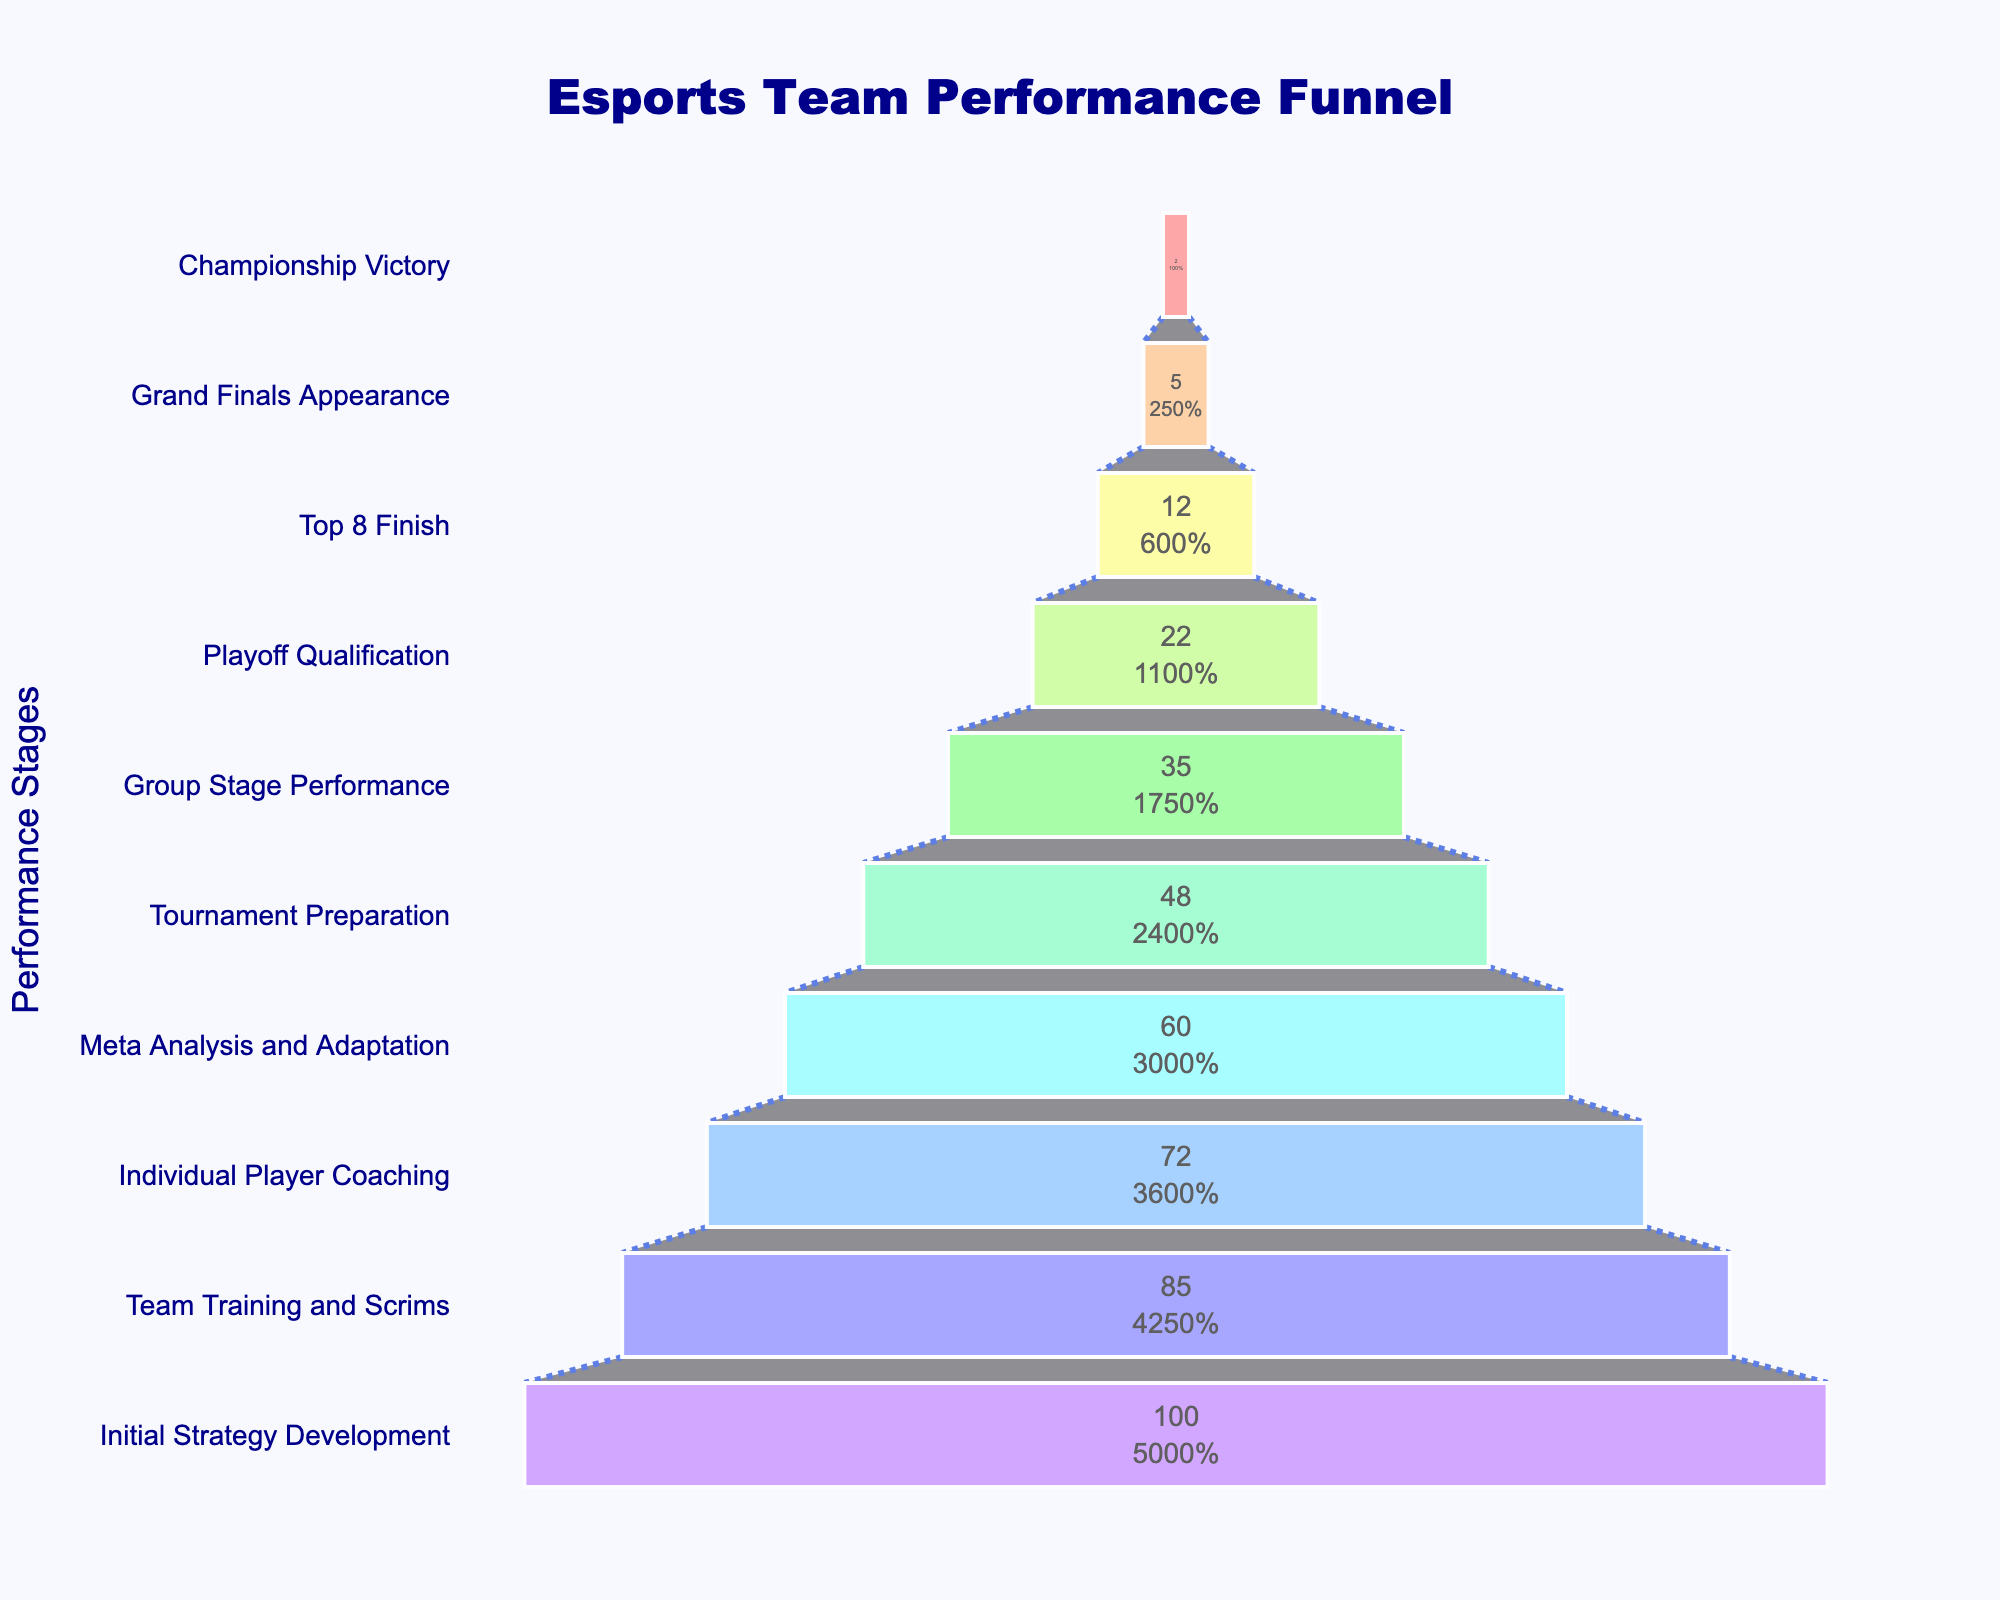How many teams participated in initial strategy development? The first stage shown in the funnel chart is "Initial Strategy Development," and it lists the number of teams as shown in the value.
Answer: 100 Which stage has the lowest number of teams? By looking at the bottom of the funnel, we can see that the stage "Championship Victory" has the smallest value in terms of the number of teams.
Answer: Championship Victory What's the change in the number of teams from "Team Training and Scrims" to "Individual Player Coaching"? To find the change, we subtract the number of teams at the "Individual Player Coaching" stage from "Team Training and Scrims": 85 - 72 = 13.
Answer: 13 What percentage of teams move from "Group Stage Performance" to "Playoff Qualification"? To calculate the percentage, we use the formula: (Teams in "Playoff Qualification"/Teams in "Group Stage Performance") * 100. This is (22/35) * 100 ≈ 62.86%.
Answer: 62.86% Which stage sees the largest drop in the number of teams? We look for the biggest difference between consecutive stages. The largest drop is between "Group Stage Performance" (35 teams) and "Playoff Qualification" (22 teams), which is 35 - 22 = 13 teams.
Answer: Group Stage Performance to Playoff Qualification What is the average number of teams from "Initial Strategy Development" to "Tournament Preparation"? Add the number of teams from these stages and divide by the number of stages: (100 + 85 + 72 + 60 + 48) / 5 = 365 / 5 = 73.
Answer: 73 How many stages are shown in the funnel chart? Counting the number of distinct stages listed on the y-axis of the funnel chart gives the total number of stages.
Answer: 10 Are there more teams in "Meta Analysis and Adaptation" than "Group Stage Performance"? Compare the values of both stages in the chart; "Meta Analysis and Adaptation" has 60 teams while "Group Stage Performance" has 35 teams.
Answer: Yes What's the percentage drop in the number of teams from the "Top 8 Finish" to "Grand Finals Appearance"? First, find the difference in the number of teams: 12 - 5 = 7. Then, compute the percentage drop: (7/12) * 100 ≈ 58.33%.
Answer: 58.33% How many teams are expected to reach the "Grand Finals Appearance" stage based on the chart? According to the value shown at this stage in the funnel chart, it indicates the number of teams reaching the "Grand Finals Appearance".
Answer: 5 